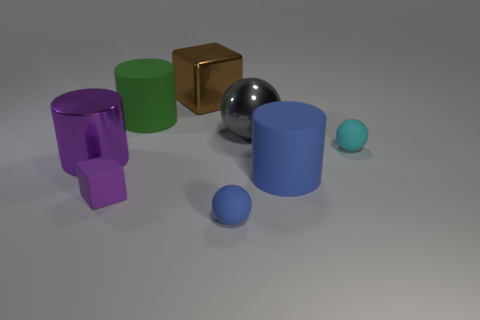Subtract all matte balls. How many balls are left? 1 Add 1 large blue rubber cylinders. How many objects exist? 9 Subtract all blue balls. How many balls are left? 2 Subtract 1 spheres. How many spheres are left? 2 Subtract all cylinders. How many objects are left? 5 Subtract all red cylinders. Subtract all cyan blocks. How many cylinders are left? 3 Subtract all green cubes. Subtract all large metallic cubes. How many objects are left? 7 Add 1 blue rubber spheres. How many blue rubber spheres are left? 2 Add 3 large red cubes. How many large red cubes exist? 3 Subtract 1 blue balls. How many objects are left? 7 